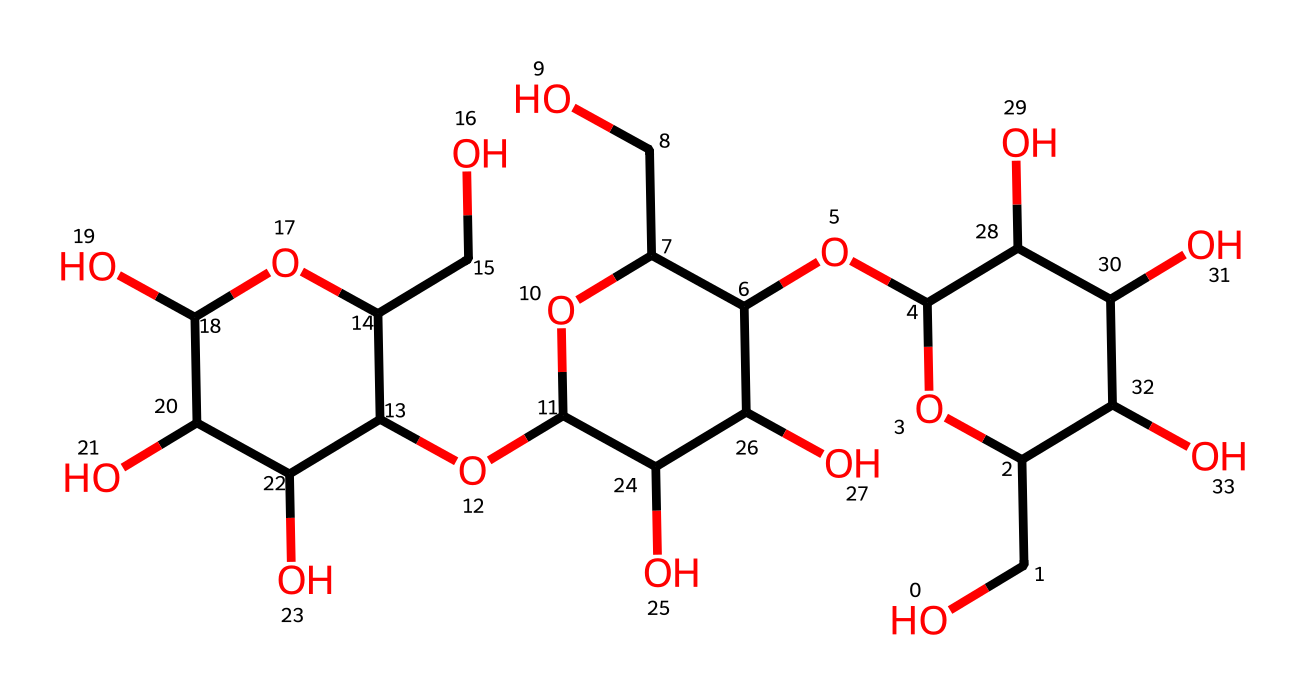What is the main functional group present in this structure? The structure contains multiple hydroxyl (-OH) groups, which are characteristic of alcohols and polysaccharides. By identifying the -OH groups in the molecular arrangement, we can determine the presence of the alcohol functional group.
Answer: alcohol How many carbon atoms are in this molecule? By visualizing the structure and counting the total number of carbon atoms present in the arrangement, we can confirm that there are a total of 12 carbon atoms evident from the structure.
Answer: 12 What type of chemical bond predominates in this compound? Analyzing the bonds between the atoms, we see that numerous single covalent bonds connect the carbon, oxygen, and hydrogen atoms. This predominance of single bonds indicates that the chemical mainly features covalent bonding.
Answer: covalent bonds What type of cosmetic function might this chemical serve? Given the presence of multiple hydroxyl groups and the polysaccharide characteristics, this compound likely has moisturizing properties, which are beneficial in cosmetic formulations for hydrating skin.
Answer: moisturizing What is the potential environmental advantage of using this molecule? This molecule is derived from sustainable sources, as indicated by its structural complexity and potential natural origin, suggesting reduced environmental impact compared to traditional synthetic silicones.
Answer: reduced impact How many hydroxyl groups can be identified in this molecule? Upon examining the structure, there are 7 hydroxyl (-OH) groups present. This can be counted by locating each -OH attachment in the molecular arrangement.
Answer: 7 